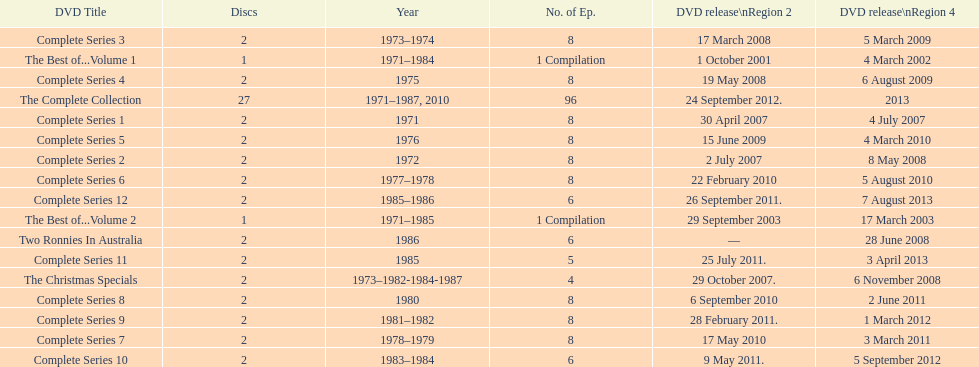What is the total of all dics listed in the table? 57. 